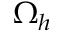Convert formula to latex. <formula><loc_0><loc_0><loc_500><loc_500>\Omega _ { h }</formula> 